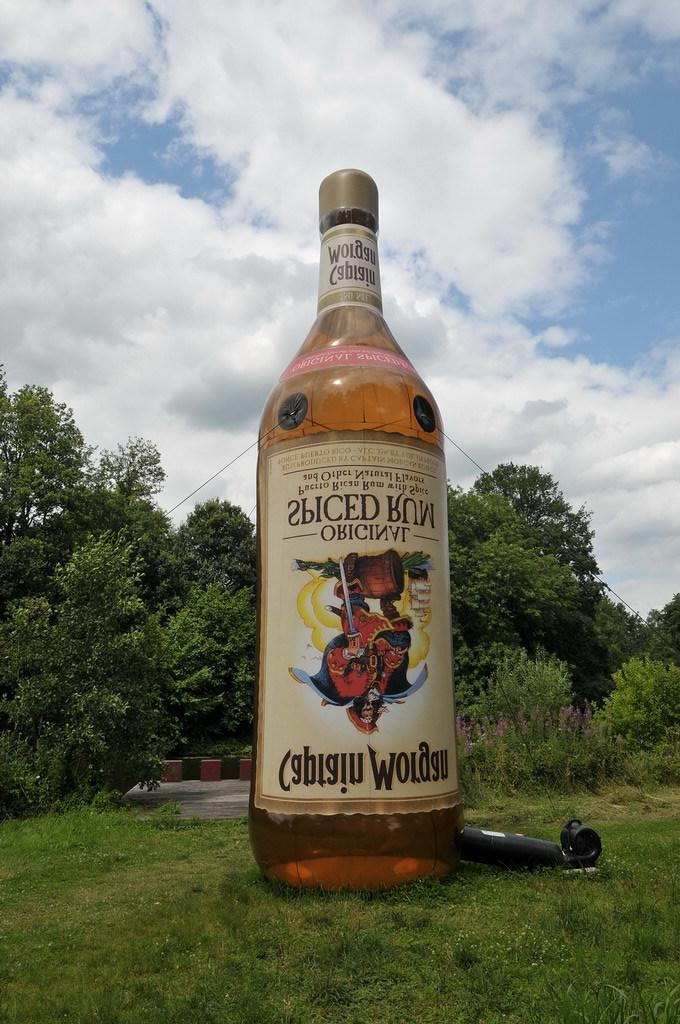<image>
Share a concise interpretation of the image provided. Brown bottle of Janiciro Spiced Rum outdoors on the ground. 